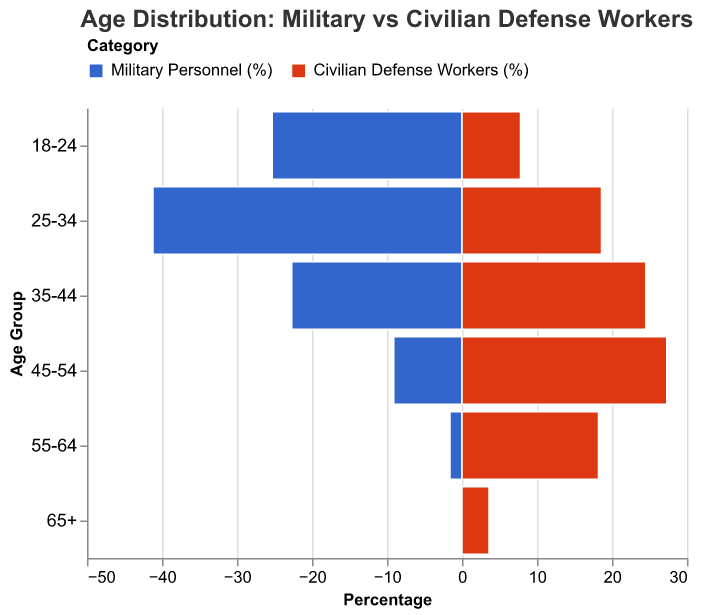What's the age group with the highest percentage of military personnel? By looking at the bar lengths representing military personnel percentages in the population pyramid, the age group with the highest percentage is the one with the longest bar.
Answer: 25-34 What's the difference in percentage between military personnel and civilian defense workers in the 45-54 age group? For the 45-54 age group, referrer to the bars representing military personnel and civilian defense workers. Subtract the percentage of military personnel (9.1%) from the percentage of civilian defense workers (27.3%).
Answer: 18.2% Which age group has the highest percentage of civilian defense workers? By examining the bar lengths for civilian defense workers across different age groups, the longest bar represents the highest percentage.
Answer: 45-54 For the age group 55-64, what is the ratio of civilian defense workers to military personnel? Look at the percentages for the 55-64 age group. Civilian defense workers are 18.2%, and military personnel are 1.6%. Divide the percentage of civilian defense workers by the percentage of military personnel.
Answer: 18.2 / 1.6 Are there any age groups where military personnel outnumber civilian defense workers? Compare the bars for each age group. If the bar for military personnel is longer than the bar for civilian defense workers, then military personnel outnumber them.
Answer: Yes, 18-24 and 25-34 Which age group shows the smallest difference in percentages between military personnel and civilian defense workers? Calculate the differences for each age group and compare. The group with the smallest absolute difference is the answer.
Answer: 35-44 How does the percentage of military personnel in the 18-24 age group compare to that in the 25-34 age group? Compare the lengths of the bars for military personnel in these age groups.
Answer: 25-34 is greater What is the combined percentage of civilian defense workers in the 45-54 and 55-64 age groups? Add the percentages of civilian defense workers in these age groups together: 27.3% + 18.2%.
Answer: 45.5% What trends can you observe regarding the age distribution of the military and civilian defense workforce? Observe how the percentages change across the age groups.
Answer: Younger age groups have higher percentages of military personnel, while older age groups have higher percentages of civilian defense workers 